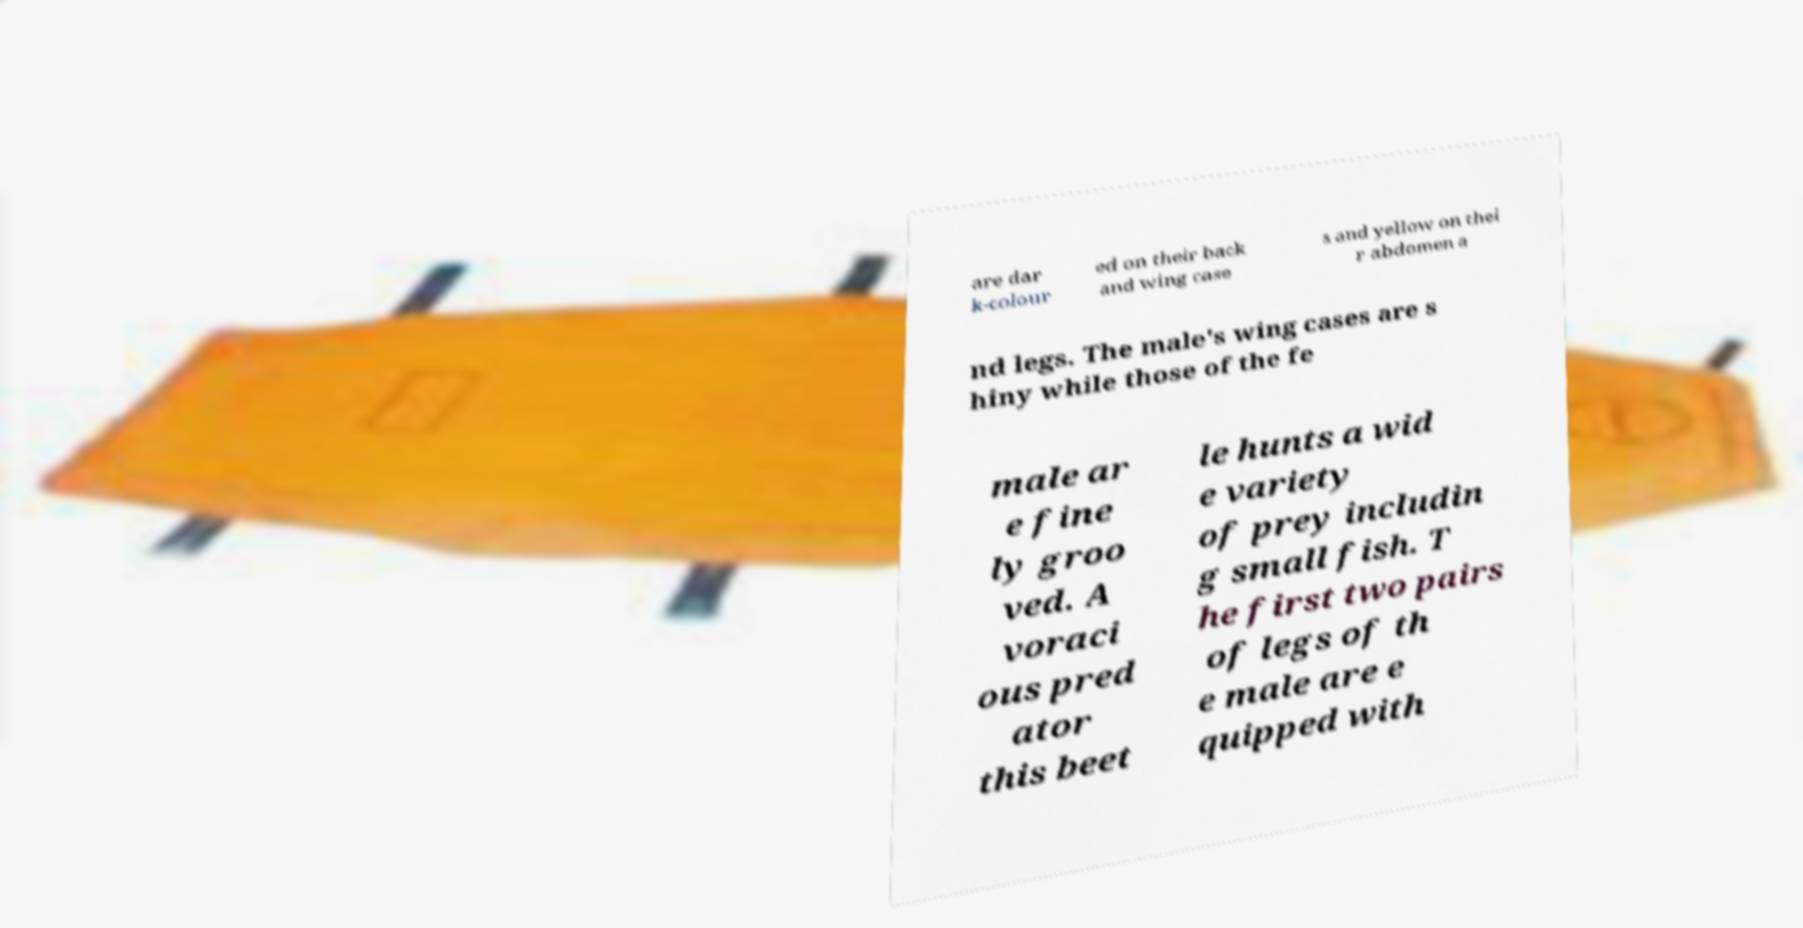Could you assist in decoding the text presented in this image and type it out clearly? are dar k-colour ed on their back and wing case s and yellow on thei r abdomen a nd legs. The male's wing cases are s hiny while those of the fe male ar e fine ly groo ved. A voraci ous pred ator this beet le hunts a wid e variety of prey includin g small fish. T he first two pairs of legs of th e male are e quipped with 